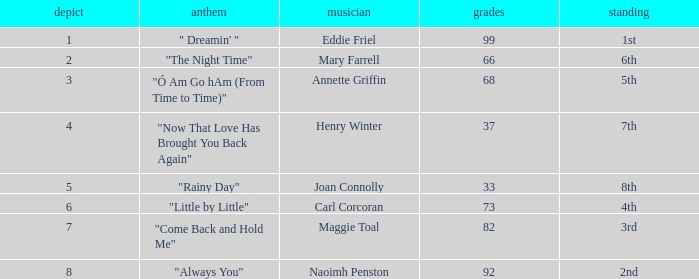Write the full table. {'header': ['depict', 'anthem', 'musician', 'grades', 'standing'], 'rows': [['1', '" Dreamin\' "', 'Eddie Friel', '99', '1st'], ['2', '"The Night Time"', 'Mary Farrell', '66', '6th'], ['3', '"Ó Am Go hAm (From Time to Time)"', 'Annette Griffin', '68', '5th'], ['4', '"Now That Love Has Brought You Back Again"', 'Henry Winter', '37', '7th'], ['5', '"Rainy Day"', 'Joan Connolly', '33', '8th'], ['6', '"Little by Little"', 'Carl Corcoran', '73', '4th'], ['7', '"Come Back and Hold Me"', 'Maggie Toal', '82', '3rd'], ['8', '"Always You"', 'Naoimh Penston', '92', '2nd']]} Which track contains more than 66 points, a stalemate greater than 3, and has a 3rd ranking? "Come Back and Hold Me". 